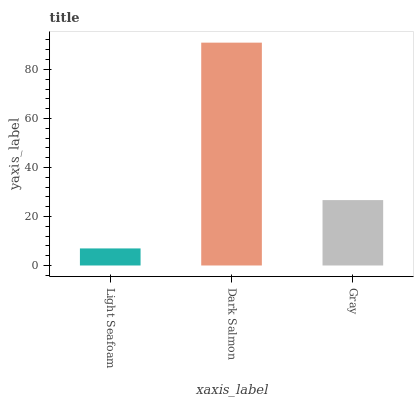Is Gray the minimum?
Answer yes or no. No. Is Gray the maximum?
Answer yes or no. No. Is Dark Salmon greater than Gray?
Answer yes or no. Yes. Is Gray less than Dark Salmon?
Answer yes or no. Yes. Is Gray greater than Dark Salmon?
Answer yes or no. No. Is Dark Salmon less than Gray?
Answer yes or no. No. Is Gray the high median?
Answer yes or no. Yes. Is Gray the low median?
Answer yes or no. Yes. Is Dark Salmon the high median?
Answer yes or no. No. Is Light Seafoam the low median?
Answer yes or no. No. 